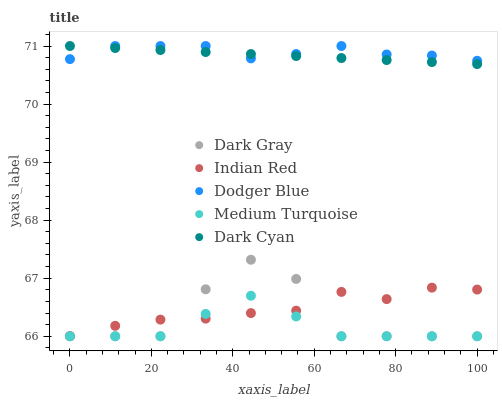Does Medium Turquoise have the minimum area under the curve?
Answer yes or no. Yes. Does Dodger Blue have the maximum area under the curve?
Answer yes or no. Yes. Does Dark Cyan have the minimum area under the curve?
Answer yes or no. No. Does Dark Cyan have the maximum area under the curve?
Answer yes or no. No. Is Dark Cyan the smoothest?
Answer yes or no. Yes. Is Dark Gray the roughest?
Answer yes or no. Yes. Is Dodger Blue the smoothest?
Answer yes or no. No. Is Dodger Blue the roughest?
Answer yes or no. No. Does Dark Gray have the lowest value?
Answer yes or no. Yes. Does Dark Cyan have the lowest value?
Answer yes or no. No. Does Dodger Blue have the highest value?
Answer yes or no. Yes. Does Medium Turquoise have the highest value?
Answer yes or no. No. Is Indian Red less than Dark Cyan?
Answer yes or no. Yes. Is Dark Cyan greater than Dark Gray?
Answer yes or no. Yes. Does Dodger Blue intersect Dark Cyan?
Answer yes or no. Yes. Is Dodger Blue less than Dark Cyan?
Answer yes or no. No. Is Dodger Blue greater than Dark Cyan?
Answer yes or no. No. Does Indian Red intersect Dark Cyan?
Answer yes or no. No. 